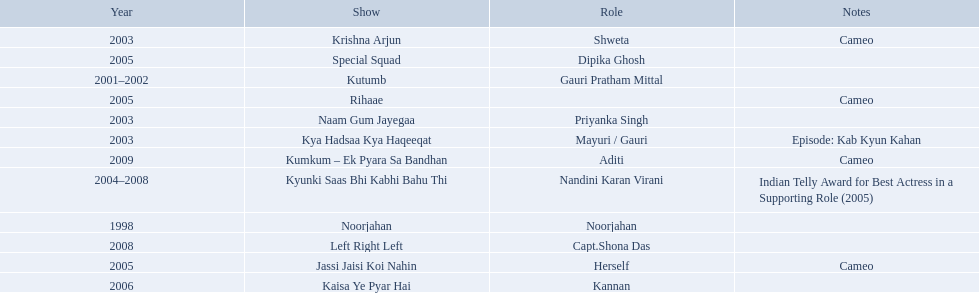How many shows are there? Noorjahan, Kutumb, Krishna Arjun, Naam Gum Jayegaa, Kya Hadsaa Kya Haqeeqat, Kyunki Saas Bhi Kabhi Bahu Thi, Rihaae, Jassi Jaisi Koi Nahin, Special Squad, Kaisa Ye Pyar Hai, Left Right Left, Kumkum – Ek Pyara Sa Bandhan. How many shows did she make a cameo appearance? Krishna Arjun, Rihaae, Jassi Jaisi Koi Nahin, Kumkum – Ek Pyara Sa Bandhan. Of those, how many did she play herself? Jassi Jaisi Koi Nahin. 